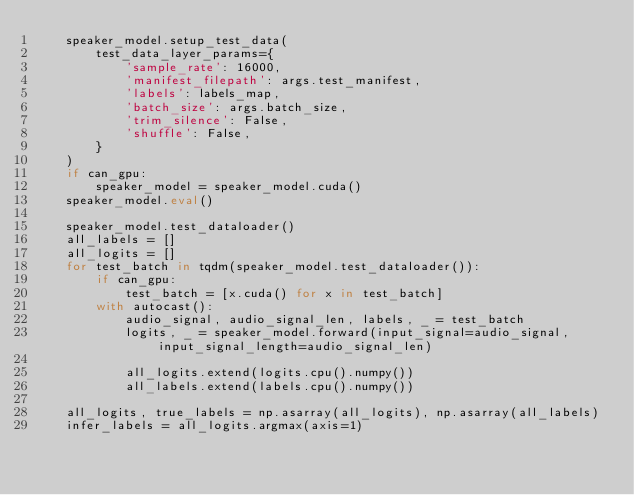Convert code to text. <code><loc_0><loc_0><loc_500><loc_500><_Python_>    speaker_model.setup_test_data(
        test_data_layer_params={
            'sample_rate': 16000,
            'manifest_filepath': args.test_manifest,
            'labels': labels_map,
            'batch_size': args.batch_size,
            'trim_silence': False,
            'shuffle': False,
        }
    )
    if can_gpu:
        speaker_model = speaker_model.cuda()
    speaker_model.eval()

    speaker_model.test_dataloader()
    all_labels = []
    all_logits = []
    for test_batch in tqdm(speaker_model.test_dataloader()):
        if can_gpu:
            test_batch = [x.cuda() for x in test_batch]
        with autocast():
            audio_signal, audio_signal_len, labels, _ = test_batch
            logits, _ = speaker_model.forward(input_signal=audio_signal, input_signal_length=audio_signal_len)

            all_logits.extend(logits.cpu().numpy())
            all_labels.extend(labels.cpu().numpy())

    all_logits, true_labels = np.asarray(all_logits), np.asarray(all_labels)
    infer_labels = all_logits.argmax(axis=1)
</code> 